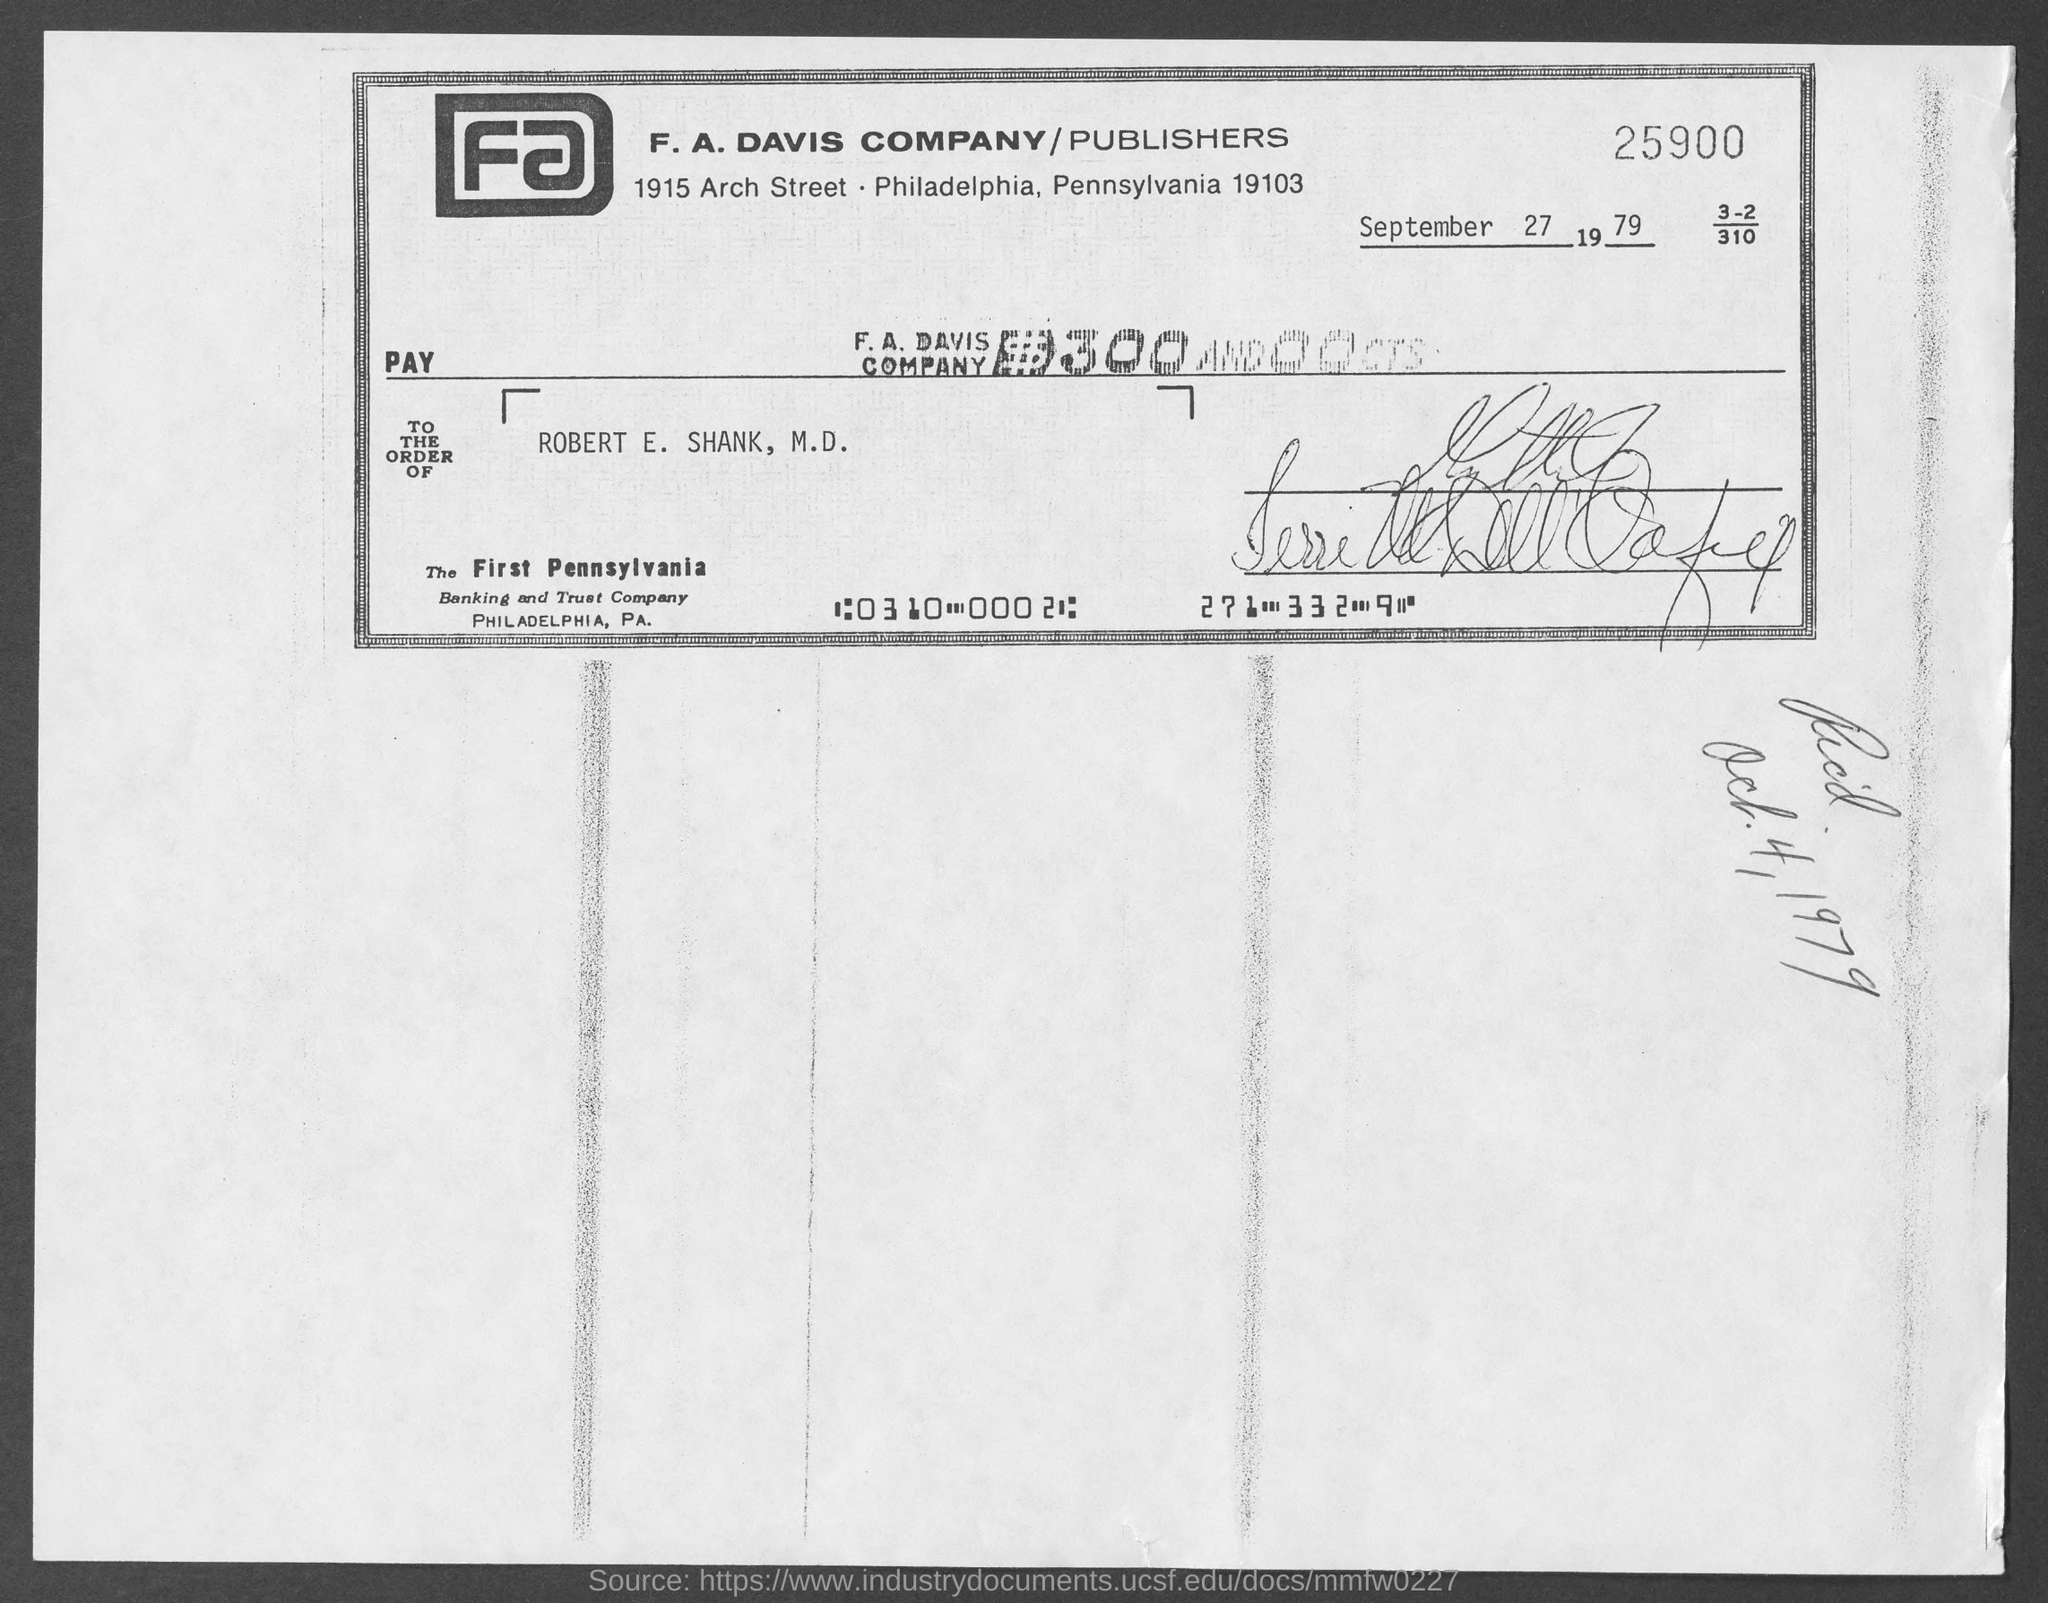When is the document dated?
Your answer should be compact. September 27 1979. To the order of whom is the document?
Keep it short and to the point. ROBERT E. SHANK, M.D. 